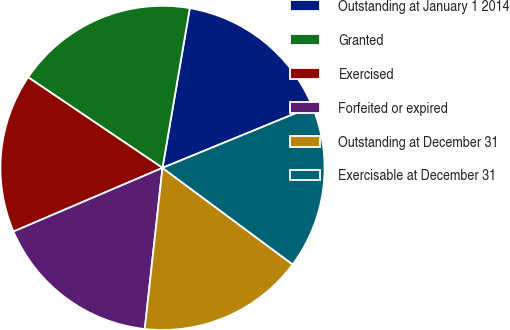<chart> <loc_0><loc_0><loc_500><loc_500><pie_chart><fcel>Outstanding at January 1 2014<fcel>Granted<fcel>Exercised<fcel>Forfeited or expired<fcel>Outstanding at December 31<fcel>Exercisable at December 31<nl><fcel>16.11%<fcel>18.25%<fcel>15.87%<fcel>16.83%<fcel>16.59%<fcel>16.35%<nl></chart> 